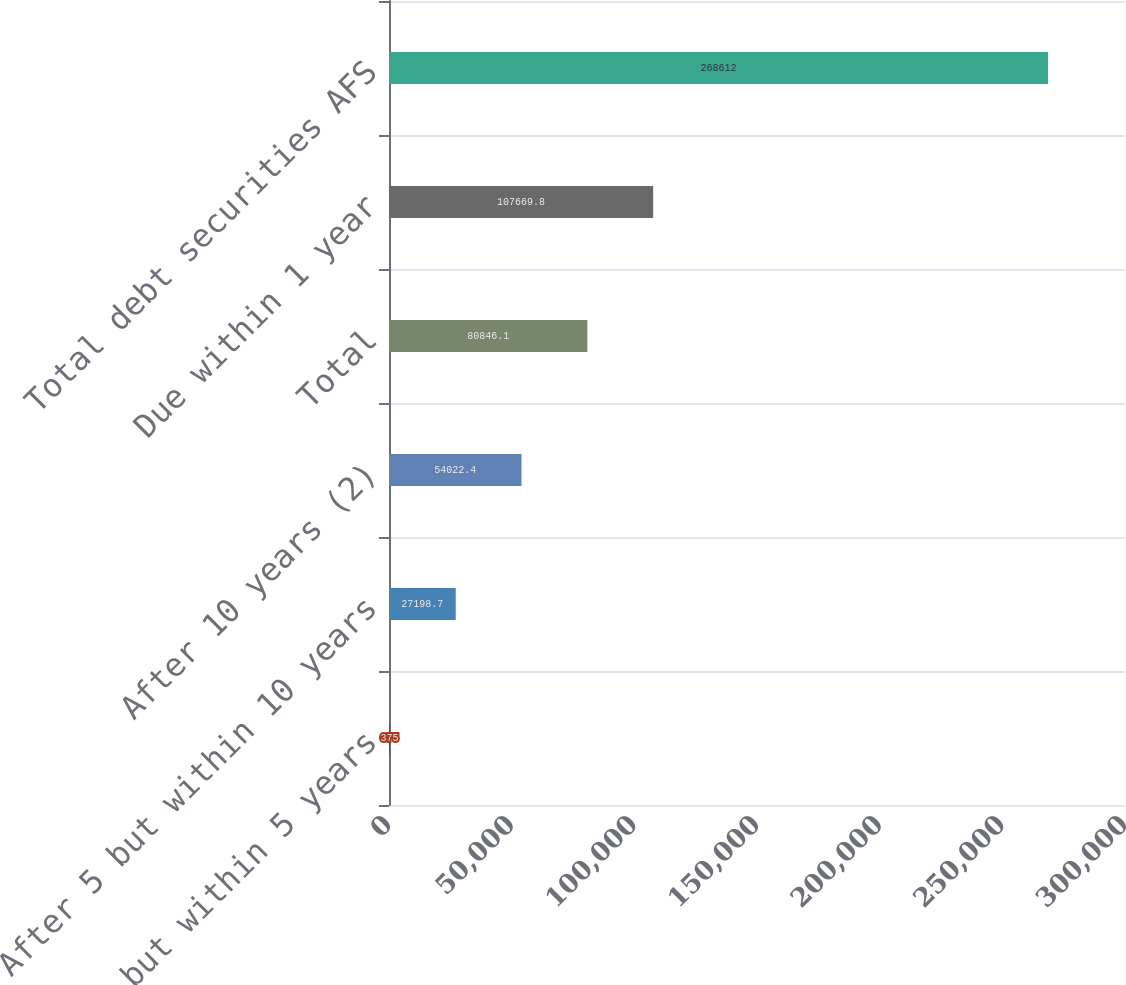<chart> <loc_0><loc_0><loc_500><loc_500><bar_chart><fcel>After 1 but within 5 years<fcel>After 5 but within 10 years<fcel>After 10 years (2)<fcel>Total<fcel>Due within 1 year<fcel>Total debt securities AFS<nl><fcel>375<fcel>27198.7<fcel>54022.4<fcel>80846.1<fcel>107670<fcel>268612<nl></chart> 